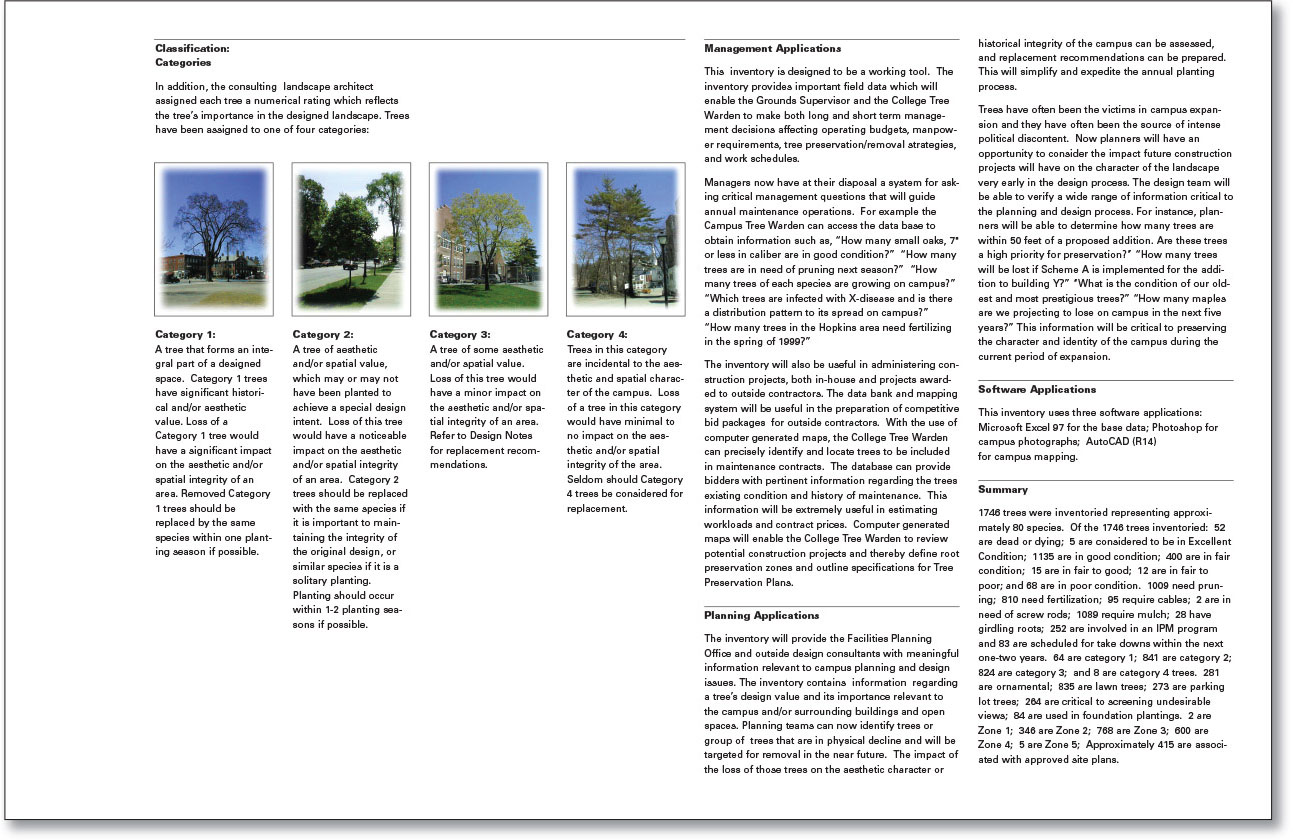What are the software applications mentioned for managing this tree inventory and how do they assist in campus management? The inventory uses three software applications: Microsoft Excel 97 for the database, Photoshop for campus photographs, and AutoCAD (R14) for campus mapping. Excel is used to organize and analyze data on the trees, making it easier for campus staff to manage and update information. Photoshop provides high-quality visuals of the trees, aiding in accurate identification and assessment. AutoCAD assists in creating detailed maps that incorporate tree locations, essential for planning and maintenance tasks. These tools collectively streamline the process of inventory management, helping maintain the campus's aesthetic and historical integrity. 